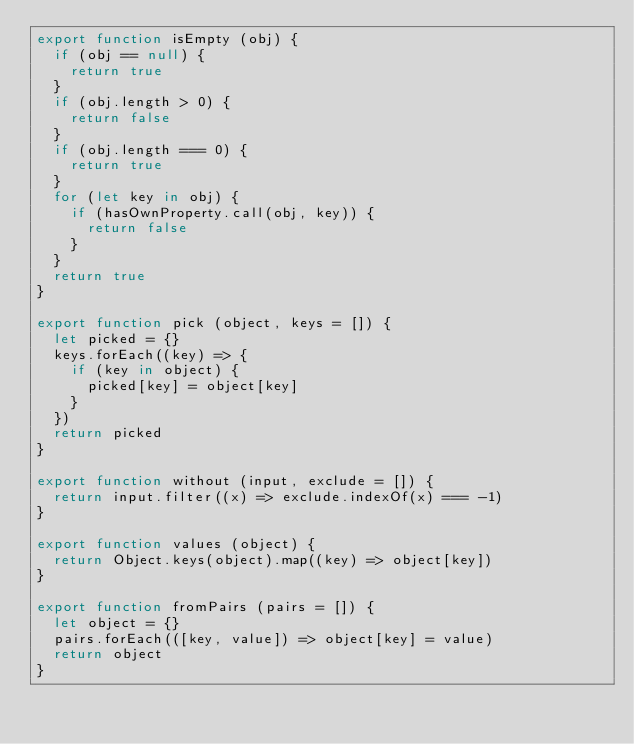Convert code to text. <code><loc_0><loc_0><loc_500><loc_500><_JavaScript_>export function isEmpty (obj) {
  if (obj == null) {
    return true
  }
  if (obj.length > 0) {
    return false
  }
  if (obj.length === 0) {
    return true
  }
  for (let key in obj) {
    if (hasOwnProperty.call(obj, key)) {
      return false
    }
  }
  return true
}

export function pick (object, keys = []) {
  let picked = {}
  keys.forEach((key) => {
    if (key in object) {
      picked[key] = object[key]
    }
  })
  return picked
}

export function without (input, exclude = []) {
	return input.filter((x) => exclude.indexOf(x) === -1)
}

export function values (object) {
  return Object.keys(object).map((key) => object[key])
}

export function fromPairs (pairs = []) {
  let object = {}
  pairs.forEach(([key, value]) => object[key] = value)
  return object
}
</code> 